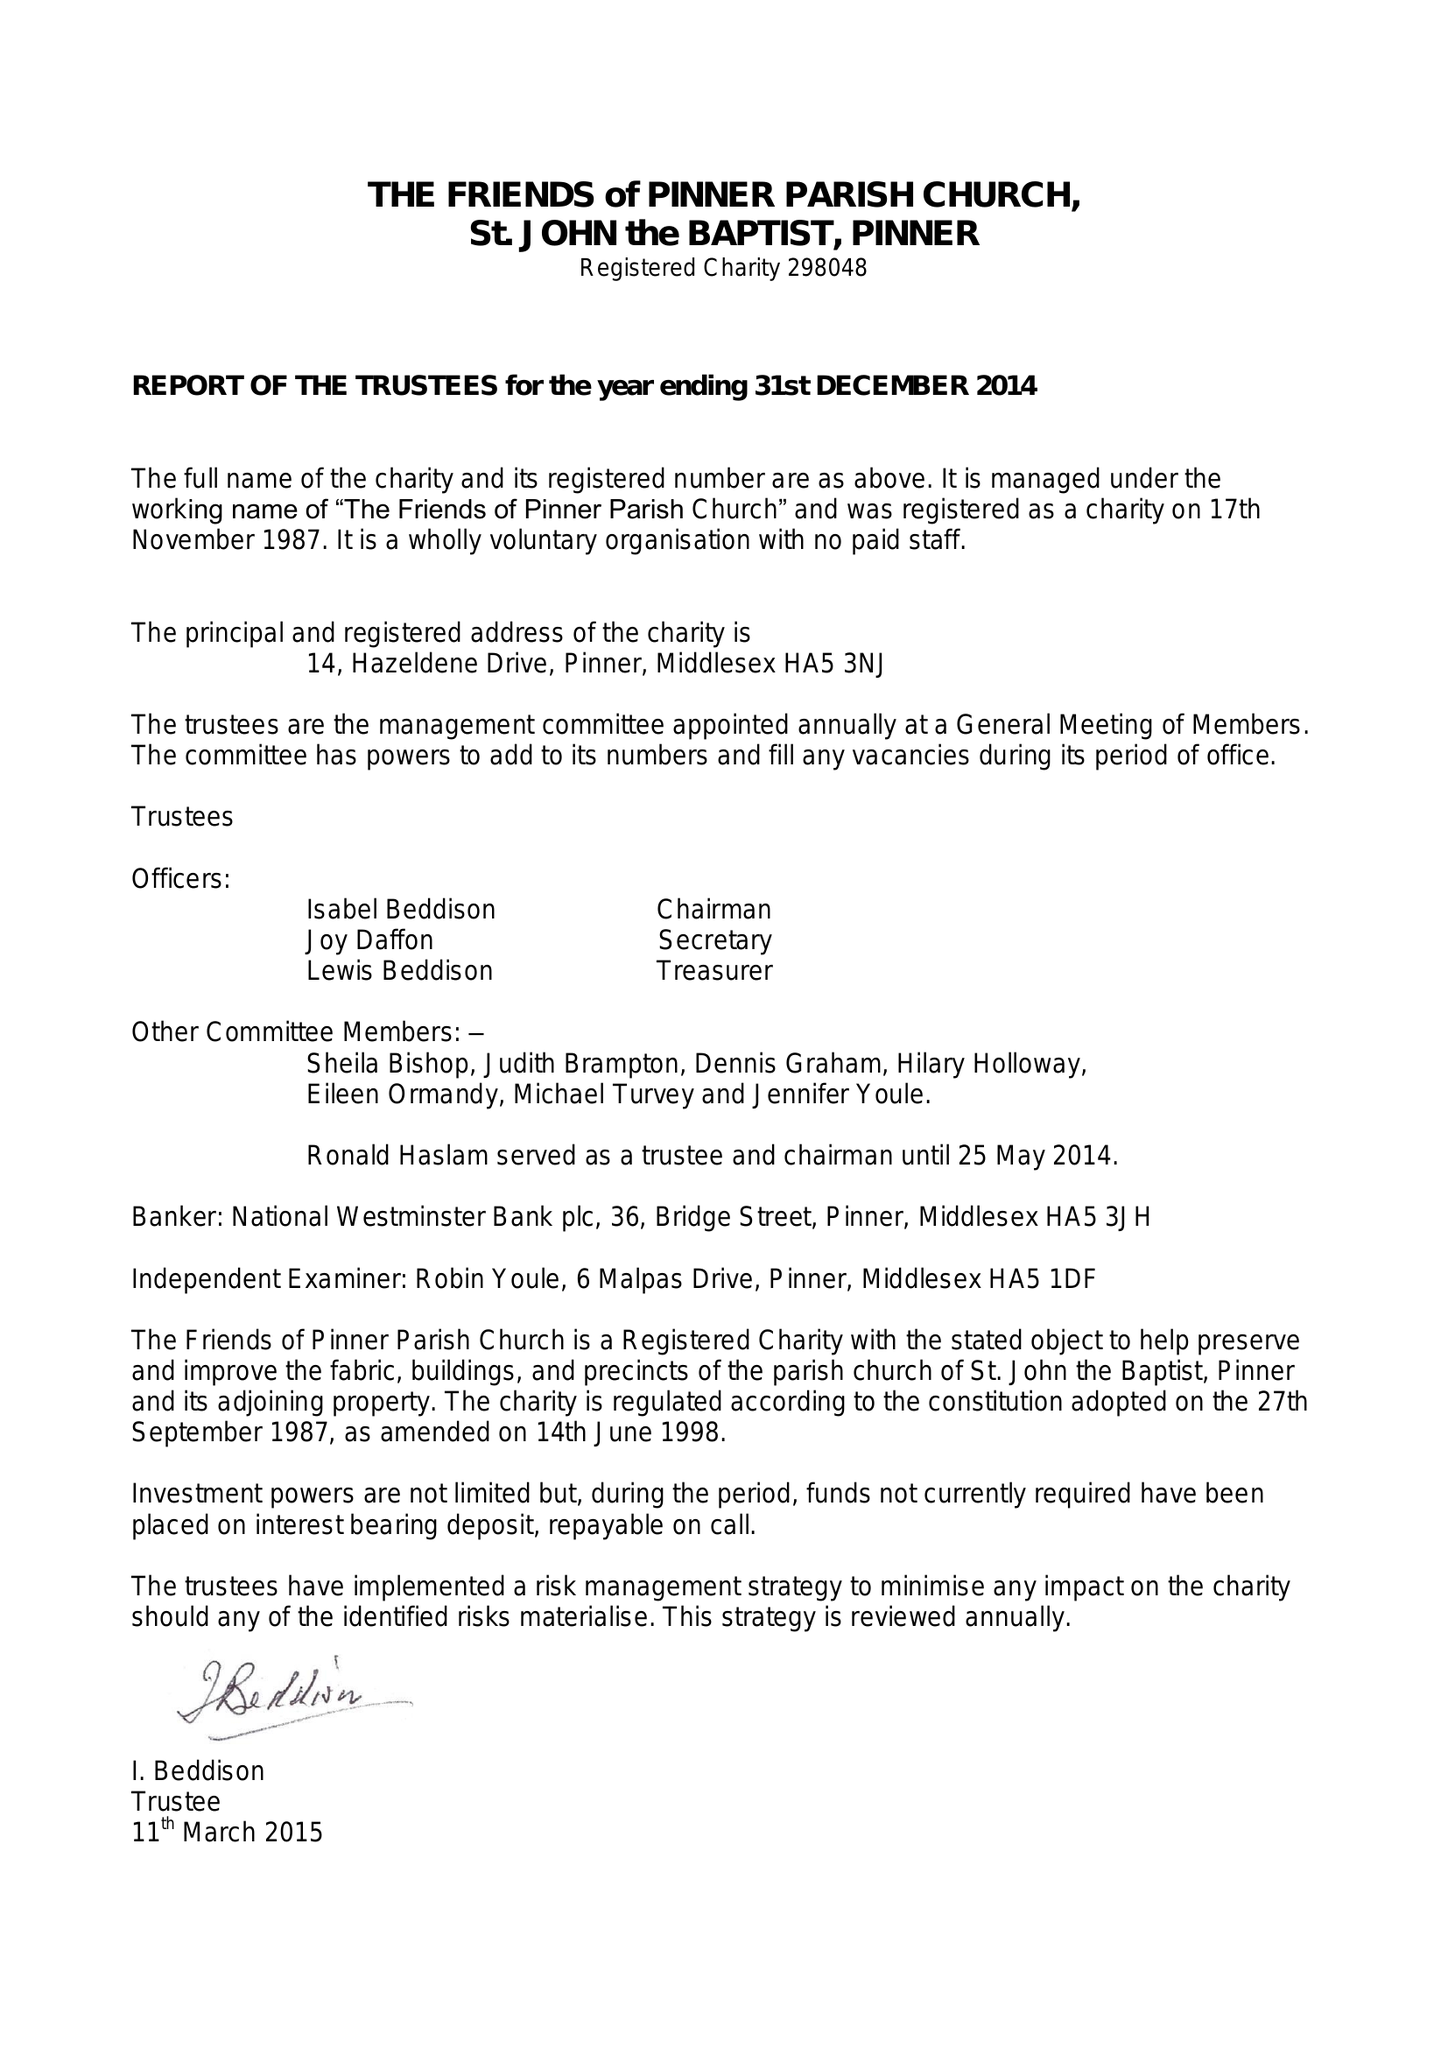What is the value for the report_date?
Answer the question using a single word or phrase. 2014-12-31 